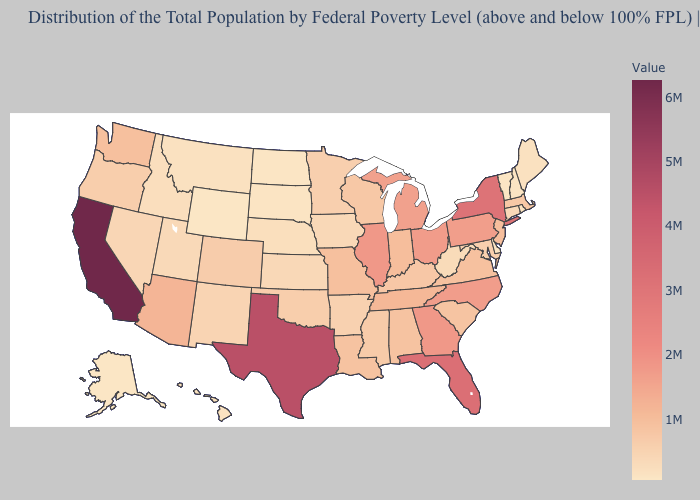Does the map have missing data?
Keep it brief. No. Does Illinois have the highest value in the MidWest?
Give a very brief answer. Yes. Which states have the highest value in the USA?
Answer briefly. California. Does Vermont have the lowest value in the Northeast?
Quick response, please. Yes. Does New York have the highest value in the Northeast?
Short answer required. Yes. 